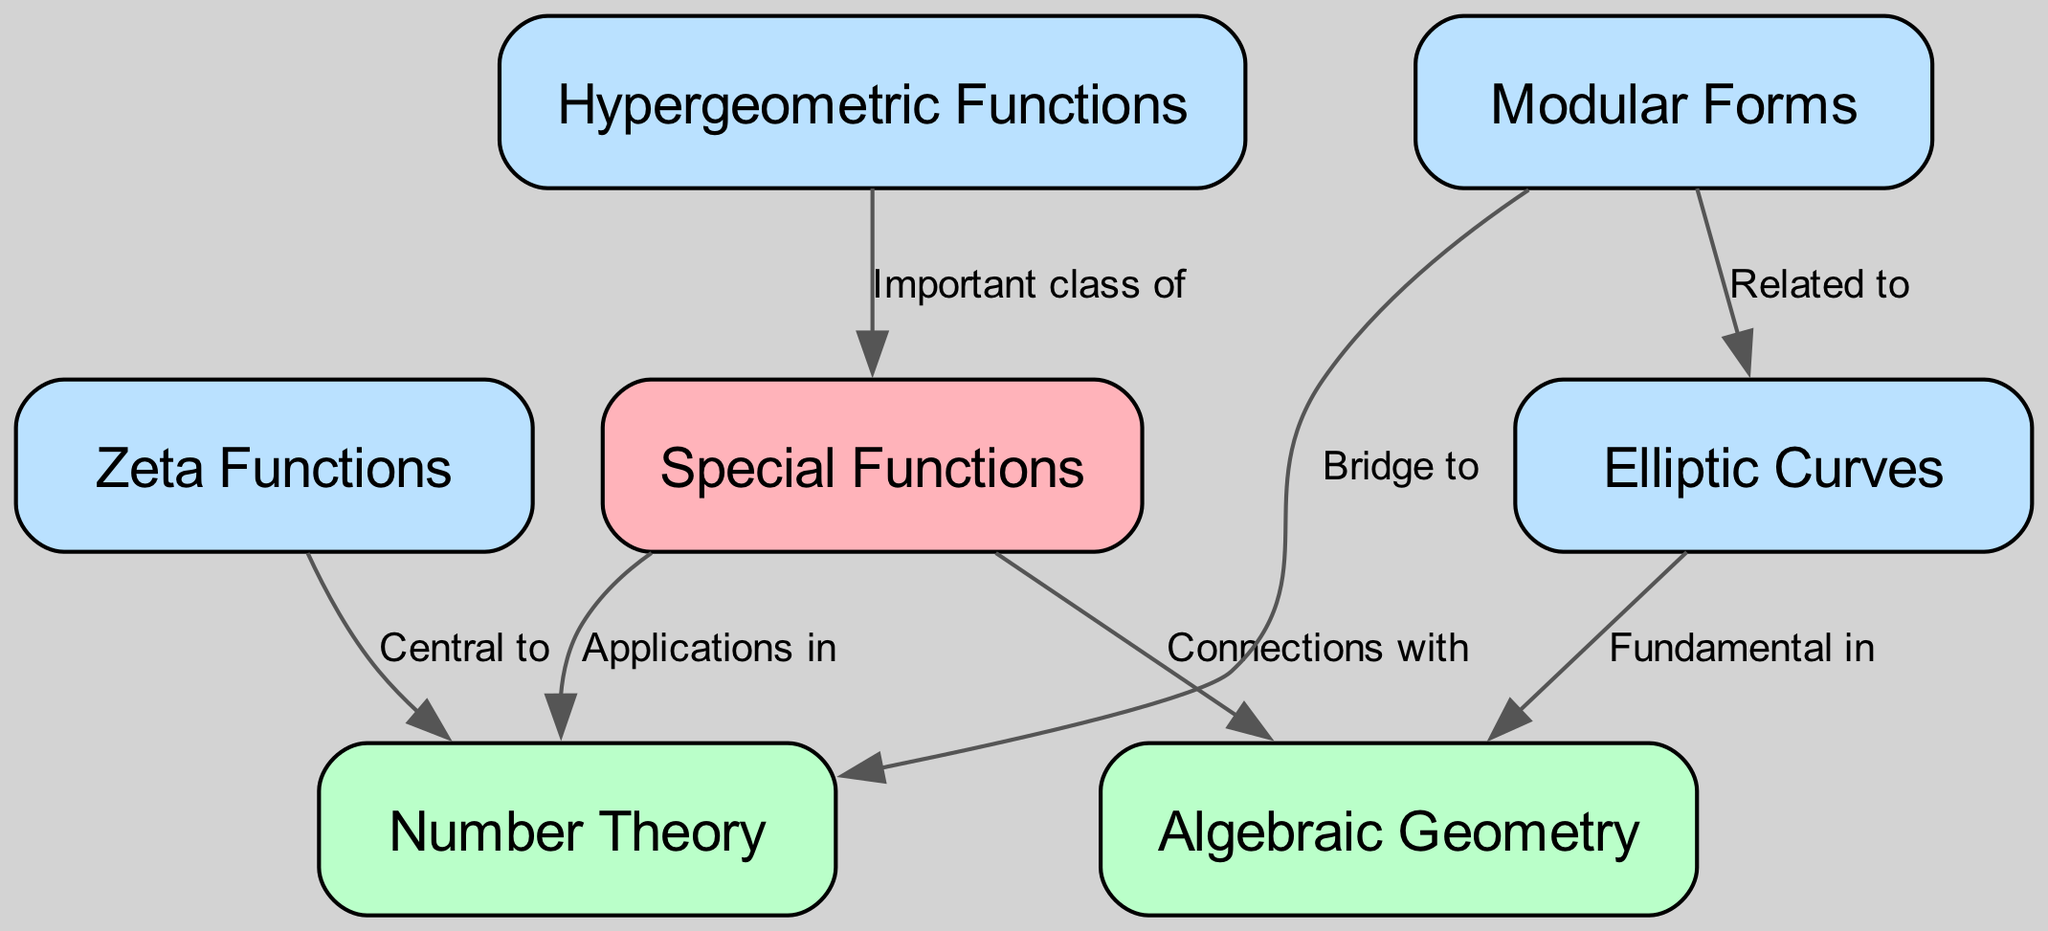What connection does "Special Functions" have with "Number Theory"? The edge connecting "Special Functions" and "Number Theory" is labeled "Applications in," indicating that special functions have practical applications within the field of number theory.
Answer: Applications in Which area is indicated to be central to "Number Theory"? The edge from "Zeta Functions" to "Number Theory" is labeled "Central to," showing that zeta functions play a crucial role in number theory.
Answer: Central to How many nodes are present in the diagram? The total number of unique nodes listed in the data is 7: "Special Functions," "Number Theory," "Algebraic Geometry," "Zeta Functions," "Elliptic Curves," "Modular Forms," and "Hypergeometric Functions".
Answer: 7 What is the relationship between "Elliptic Curves" and "Algebraic Geometry"? The edge from "Elliptic Curves" to "Algebraic Geometry" states "Fundamental in," suggesting that elliptic curves are a fundamental concept within algebraic geometry.
Answer: Fundamental in How are "Modular Forms" related to "Elliptic Curves"? The edge from "Modular Forms" to "Elliptic Curves" is labeled "Related to," indicating their connection and relevance to one another within the field of mathematics.
Answer: Related to What do "Special Functions" connect with, according to the diagram? The diagram indicates that "Special Functions" connect with "Algebraic Geometry," as shown by the edge label "Connections with".
Answer: Connections with In what way do "Modular Forms" serve with respect to "Number Theory"? The edge from "Modular Forms" to "Number Theory" describes them as a "Bridge to," indicating that modular forms connect different mathematical concepts within number theory.
Answer: Bridge to Which type of functions is highlighted within "Special Functions"? The "Hypergeometric Functions" node is labeled as an "Important class of" special functions, indicating their significance in this category.
Answer: Important class of 